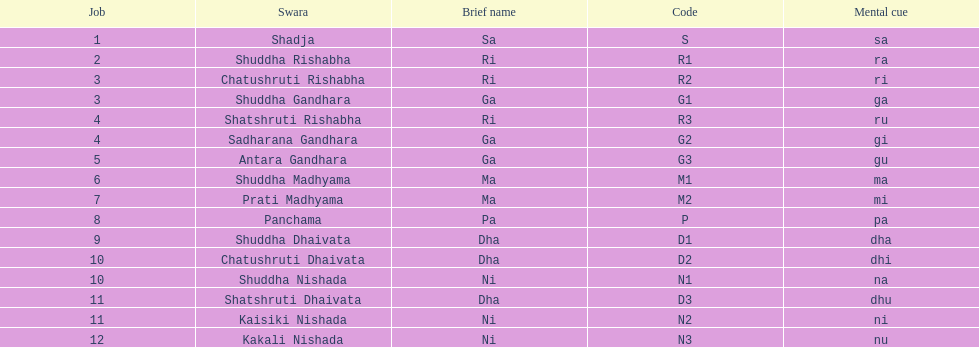List each pair of swaras that share the same position. Chatushruti Rishabha, Shuddha Gandhara, Shatshruti Rishabha, Sadharana Gandhara, Chatushruti Dhaivata, Shuddha Nishada, Shatshruti Dhaivata, Kaisiki Nishada. 